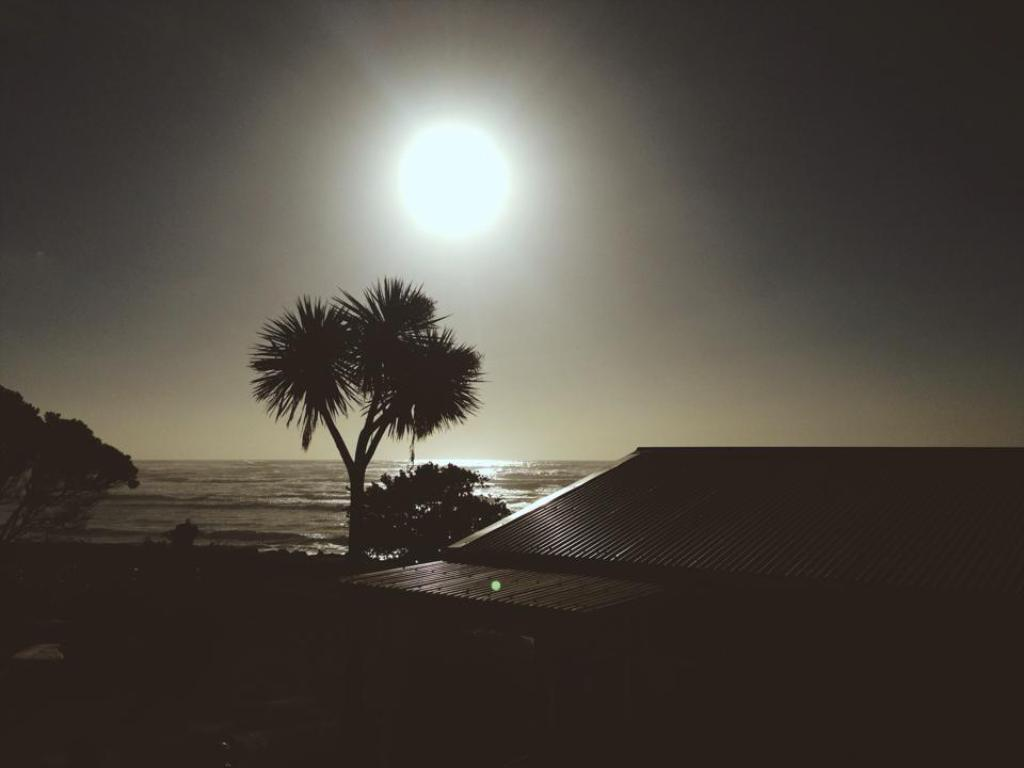What structure is located on the right side of the image? There is a building on the right side of the image. What type of natural elements can be seen in the image? There are trees and water visible in the image. What is visible in the sky in the image? The sky is visible in the image, and the sun is observable. Where is the chair located in the image? There is no chair present in the image. What type of shoe can be seen floating in the water in the image? There is no shoe present in the image; it only features a building, trees, water, and the sky. 